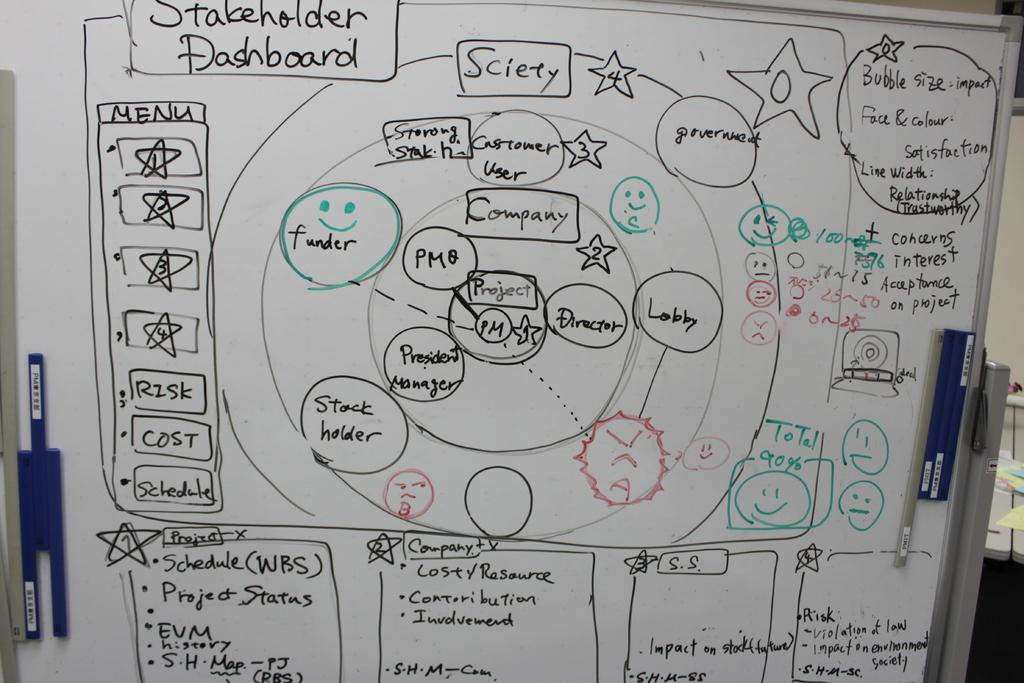<image>
Describe the image concisely. A large, complicated looking diagram which represents the Stakeholder Dashboard. 